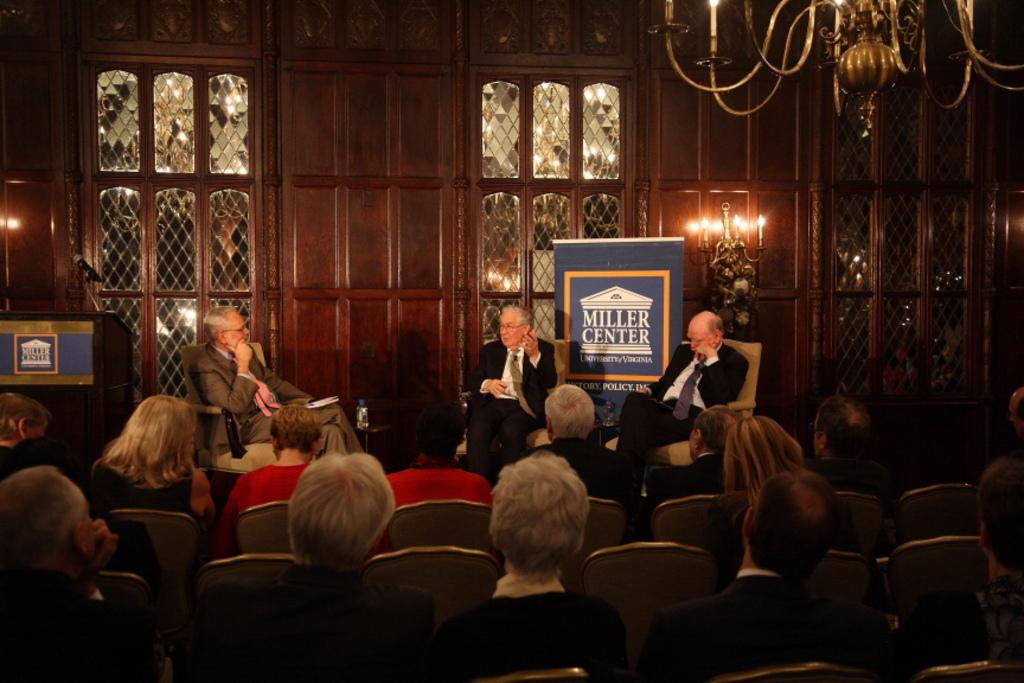In one or two sentences, can you explain what this image depicts? Here we can see a group of people sitting on chairs and in front of them we can see 3 man sitting on chairs discussing something and behind them we can see a banner and there are couple of Windows present and at the right top we can see a chandelier and in the middle we can see candles present 